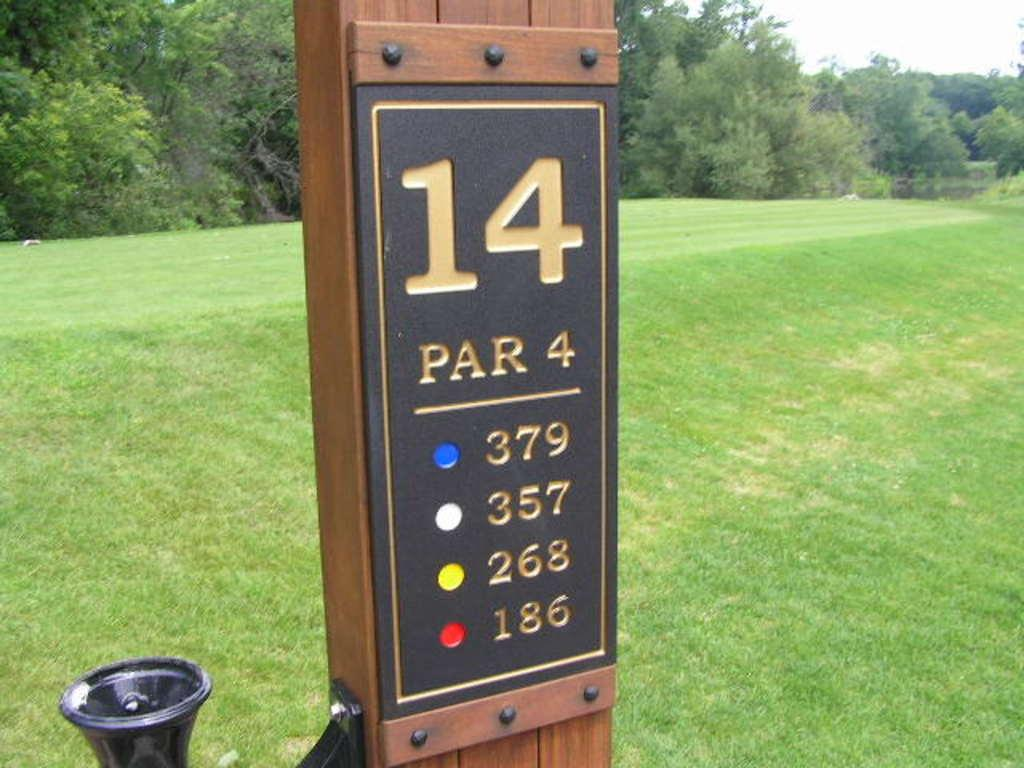What is the main object in the image? There is a wooden pole in the image. What is written on the wooden pole? Numbers are written on the wooden pole. What can be seen behind the wooden pole? There is green grass land behind the wooden pole. What type of vegetation is present in the grass land? Trees are present in the grass land. Are there any giants sleeping in the grass land in the image? There are no giants or any indication of sleeping in the image; it only features a wooden pole with numbers, green grass land, and trees. 